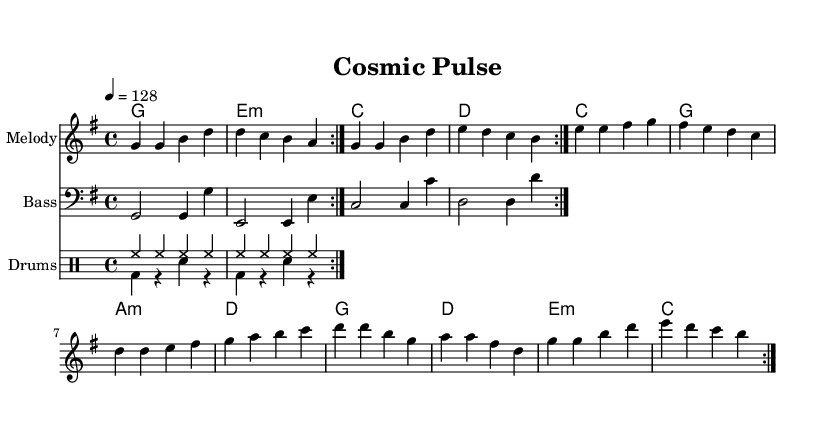What is the key signature of this music? The key signature is G major, which has one sharp (F#). You can find this in the beginning of the score, indicated by the presence of an F# in the signature line.
Answer: G major What is the time signature of this piece? The time signature is 4/4, which is indicated right after the key signature. It means there are four beats in a measure, and each quarter note gets one beat.
Answer: 4/4 What is the tempo marking for this piece? The tempo is marked as 128 beats per minute, which is indicated at the start of the score. This means the music should be played at a moderate and upbeat pace.
Answer: 128 How many times is the melody repeated? The melody is repeated twice as indicated by the "volta" markings. You can see the repeat indication at the beginning and the end of the melody section.
Answer: 2 Which chords are used in the harmonies? The chords used in the harmonies are G, E minor, C, and D, as seen in the chord names below the staff. This provides a guide to the harmonic structure throughout the piece.
Answer: G, E minor, C, D What rhythmic pattern is used for the drums? The rhythmic pattern for the drums includes a combination of high-hat and bass drum hits, alternating with snare hits, as shown in the drum staves. This creates a driving rhythm typical of upbeat electronic pop tracks.
Answer: High-hat and bass drum with snare What is the structure of the bass line? The bass line follows a simple repetitive structure, playing whole notes and quarter notes that correspond to the root notes of the chords, making it foundational and driving for the piece.
Answer: Simple repetitive structure 